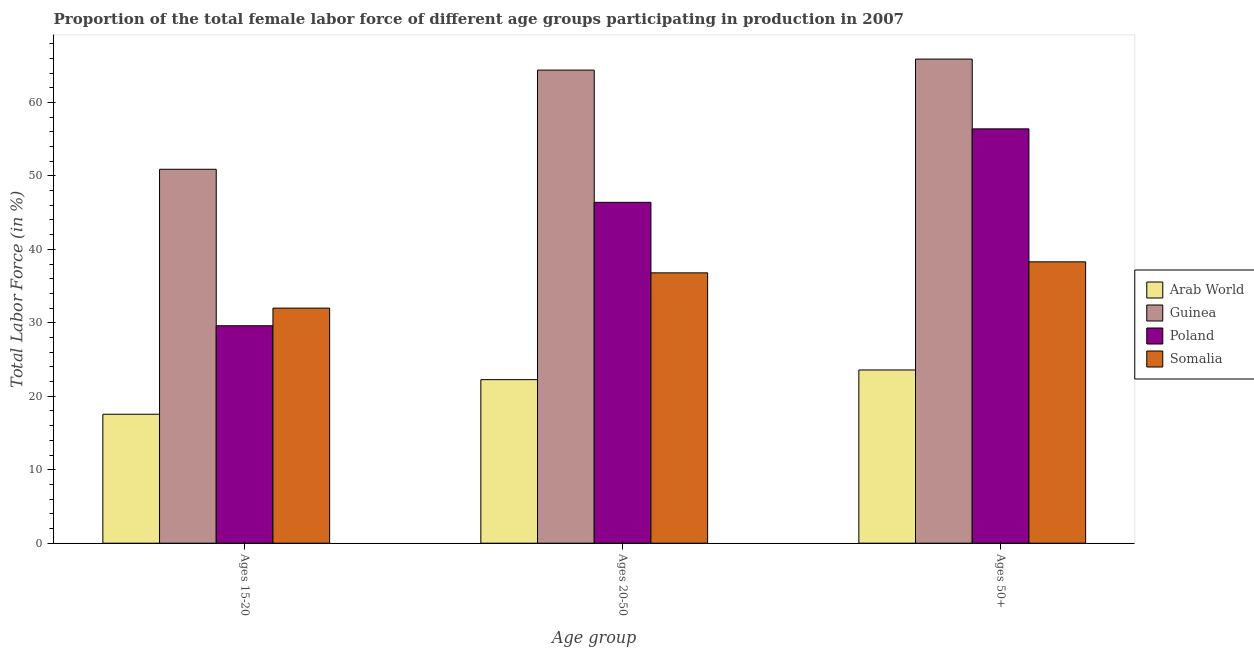How many groups of bars are there?
Give a very brief answer. 3. How many bars are there on the 1st tick from the left?
Make the answer very short. 4. How many bars are there on the 3rd tick from the right?
Your response must be concise. 4. What is the label of the 1st group of bars from the left?
Give a very brief answer. Ages 15-20. What is the percentage of female labor force within the age group 20-50 in Guinea?
Your answer should be compact. 64.4. Across all countries, what is the maximum percentage of female labor force within the age group 15-20?
Your answer should be compact. 50.9. Across all countries, what is the minimum percentage of female labor force within the age group 20-50?
Your answer should be compact. 22.26. In which country was the percentage of female labor force within the age group 15-20 maximum?
Your response must be concise. Guinea. In which country was the percentage of female labor force above age 50 minimum?
Keep it short and to the point. Arab World. What is the total percentage of female labor force within the age group 15-20 in the graph?
Make the answer very short. 130.05. What is the difference between the percentage of female labor force above age 50 in Poland and that in Somalia?
Offer a very short reply. 18.1. What is the average percentage of female labor force within the age group 20-50 per country?
Give a very brief answer. 42.47. What is the difference between the percentage of female labor force within the age group 15-20 and percentage of female labor force within the age group 20-50 in Poland?
Provide a short and direct response. -16.8. What is the ratio of the percentage of female labor force above age 50 in Guinea to that in Somalia?
Give a very brief answer. 1.72. Is the percentage of female labor force above age 50 in Guinea less than that in Somalia?
Your answer should be very brief. No. Is the difference between the percentage of female labor force within the age group 15-20 in Poland and Arab World greater than the difference between the percentage of female labor force above age 50 in Poland and Arab World?
Offer a very short reply. No. What is the difference between the highest and the second highest percentage of female labor force within the age group 15-20?
Ensure brevity in your answer.  18.9. What is the difference between the highest and the lowest percentage of female labor force within the age group 20-50?
Your response must be concise. 42.14. Is the sum of the percentage of female labor force within the age group 15-20 in Poland and Guinea greater than the maximum percentage of female labor force within the age group 20-50 across all countries?
Give a very brief answer. Yes. What does the 2nd bar from the left in Ages 15-20 represents?
Give a very brief answer. Guinea. What does the 3rd bar from the right in Ages 50+ represents?
Provide a short and direct response. Guinea. Is it the case that in every country, the sum of the percentage of female labor force within the age group 15-20 and percentage of female labor force within the age group 20-50 is greater than the percentage of female labor force above age 50?
Your answer should be very brief. Yes. How many bars are there?
Your answer should be compact. 12. Are all the bars in the graph horizontal?
Your answer should be very brief. No. How many countries are there in the graph?
Offer a terse response. 4. What is the difference between two consecutive major ticks on the Y-axis?
Your response must be concise. 10. Does the graph contain grids?
Keep it short and to the point. No. Where does the legend appear in the graph?
Make the answer very short. Center right. How many legend labels are there?
Your answer should be compact. 4. What is the title of the graph?
Provide a succinct answer. Proportion of the total female labor force of different age groups participating in production in 2007. Does "Channel Islands" appear as one of the legend labels in the graph?
Provide a succinct answer. No. What is the label or title of the X-axis?
Offer a very short reply. Age group. What is the Total Labor Force (in %) of Arab World in Ages 15-20?
Your answer should be compact. 17.55. What is the Total Labor Force (in %) in Guinea in Ages 15-20?
Your answer should be compact. 50.9. What is the Total Labor Force (in %) of Poland in Ages 15-20?
Your response must be concise. 29.6. What is the Total Labor Force (in %) of Somalia in Ages 15-20?
Your answer should be compact. 32. What is the Total Labor Force (in %) in Arab World in Ages 20-50?
Provide a short and direct response. 22.26. What is the Total Labor Force (in %) of Guinea in Ages 20-50?
Provide a succinct answer. 64.4. What is the Total Labor Force (in %) of Poland in Ages 20-50?
Keep it short and to the point. 46.4. What is the Total Labor Force (in %) in Somalia in Ages 20-50?
Offer a terse response. 36.8. What is the Total Labor Force (in %) in Arab World in Ages 50+?
Offer a terse response. 23.58. What is the Total Labor Force (in %) of Guinea in Ages 50+?
Ensure brevity in your answer.  65.9. What is the Total Labor Force (in %) of Poland in Ages 50+?
Ensure brevity in your answer.  56.4. What is the Total Labor Force (in %) of Somalia in Ages 50+?
Ensure brevity in your answer.  38.3. Across all Age group, what is the maximum Total Labor Force (in %) in Arab World?
Keep it short and to the point. 23.58. Across all Age group, what is the maximum Total Labor Force (in %) in Guinea?
Offer a very short reply. 65.9. Across all Age group, what is the maximum Total Labor Force (in %) in Poland?
Your response must be concise. 56.4. Across all Age group, what is the maximum Total Labor Force (in %) in Somalia?
Make the answer very short. 38.3. Across all Age group, what is the minimum Total Labor Force (in %) of Arab World?
Give a very brief answer. 17.55. Across all Age group, what is the minimum Total Labor Force (in %) in Guinea?
Your response must be concise. 50.9. Across all Age group, what is the minimum Total Labor Force (in %) in Poland?
Provide a short and direct response. 29.6. What is the total Total Labor Force (in %) of Arab World in the graph?
Make the answer very short. 63.4. What is the total Total Labor Force (in %) in Guinea in the graph?
Provide a succinct answer. 181.2. What is the total Total Labor Force (in %) of Poland in the graph?
Offer a very short reply. 132.4. What is the total Total Labor Force (in %) in Somalia in the graph?
Your response must be concise. 107.1. What is the difference between the Total Labor Force (in %) of Arab World in Ages 15-20 and that in Ages 20-50?
Your answer should be very brief. -4.71. What is the difference between the Total Labor Force (in %) in Poland in Ages 15-20 and that in Ages 20-50?
Make the answer very short. -16.8. What is the difference between the Total Labor Force (in %) in Somalia in Ages 15-20 and that in Ages 20-50?
Your answer should be compact. -4.8. What is the difference between the Total Labor Force (in %) of Arab World in Ages 15-20 and that in Ages 50+?
Provide a succinct answer. -6.03. What is the difference between the Total Labor Force (in %) in Poland in Ages 15-20 and that in Ages 50+?
Your answer should be very brief. -26.8. What is the difference between the Total Labor Force (in %) in Arab World in Ages 20-50 and that in Ages 50+?
Ensure brevity in your answer.  -1.32. What is the difference between the Total Labor Force (in %) of Guinea in Ages 20-50 and that in Ages 50+?
Your response must be concise. -1.5. What is the difference between the Total Labor Force (in %) of Poland in Ages 20-50 and that in Ages 50+?
Ensure brevity in your answer.  -10. What is the difference between the Total Labor Force (in %) in Somalia in Ages 20-50 and that in Ages 50+?
Keep it short and to the point. -1.5. What is the difference between the Total Labor Force (in %) in Arab World in Ages 15-20 and the Total Labor Force (in %) in Guinea in Ages 20-50?
Provide a short and direct response. -46.85. What is the difference between the Total Labor Force (in %) of Arab World in Ages 15-20 and the Total Labor Force (in %) of Poland in Ages 20-50?
Offer a terse response. -28.85. What is the difference between the Total Labor Force (in %) in Arab World in Ages 15-20 and the Total Labor Force (in %) in Somalia in Ages 20-50?
Make the answer very short. -19.25. What is the difference between the Total Labor Force (in %) in Poland in Ages 15-20 and the Total Labor Force (in %) in Somalia in Ages 20-50?
Your response must be concise. -7.2. What is the difference between the Total Labor Force (in %) in Arab World in Ages 15-20 and the Total Labor Force (in %) in Guinea in Ages 50+?
Give a very brief answer. -48.35. What is the difference between the Total Labor Force (in %) of Arab World in Ages 15-20 and the Total Labor Force (in %) of Poland in Ages 50+?
Keep it short and to the point. -38.85. What is the difference between the Total Labor Force (in %) of Arab World in Ages 15-20 and the Total Labor Force (in %) of Somalia in Ages 50+?
Provide a succinct answer. -20.75. What is the difference between the Total Labor Force (in %) of Guinea in Ages 15-20 and the Total Labor Force (in %) of Poland in Ages 50+?
Your answer should be very brief. -5.5. What is the difference between the Total Labor Force (in %) in Arab World in Ages 20-50 and the Total Labor Force (in %) in Guinea in Ages 50+?
Your answer should be very brief. -43.64. What is the difference between the Total Labor Force (in %) in Arab World in Ages 20-50 and the Total Labor Force (in %) in Poland in Ages 50+?
Give a very brief answer. -34.14. What is the difference between the Total Labor Force (in %) in Arab World in Ages 20-50 and the Total Labor Force (in %) in Somalia in Ages 50+?
Keep it short and to the point. -16.04. What is the difference between the Total Labor Force (in %) of Guinea in Ages 20-50 and the Total Labor Force (in %) of Somalia in Ages 50+?
Provide a short and direct response. 26.1. What is the difference between the Total Labor Force (in %) in Poland in Ages 20-50 and the Total Labor Force (in %) in Somalia in Ages 50+?
Give a very brief answer. 8.1. What is the average Total Labor Force (in %) of Arab World per Age group?
Provide a short and direct response. 21.13. What is the average Total Labor Force (in %) in Guinea per Age group?
Keep it short and to the point. 60.4. What is the average Total Labor Force (in %) in Poland per Age group?
Give a very brief answer. 44.13. What is the average Total Labor Force (in %) in Somalia per Age group?
Your response must be concise. 35.7. What is the difference between the Total Labor Force (in %) of Arab World and Total Labor Force (in %) of Guinea in Ages 15-20?
Provide a short and direct response. -33.35. What is the difference between the Total Labor Force (in %) of Arab World and Total Labor Force (in %) of Poland in Ages 15-20?
Your answer should be very brief. -12.05. What is the difference between the Total Labor Force (in %) of Arab World and Total Labor Force (in %) of Somalia in Ages 15-20?
Your answer should be compact. -14.45. What is the difference between the Total Labor Force (in %) of Guinea and Total Labor Force (in %) of Poland in Ages 15-20?
Offer a terse response. 21.3. What is the difference between the Total Labor Force (in %) of Guinea and Total Labor Force (in %) of Somalia in Ages 15-20?
Your answer should be very brief. 18.9. What is the difference between the Total Labor Force (in %) of Arab World and Total Labor Force (in %) of Guinea in Ages 20-50?
Your response must be concise. -42.14. What is the difference between the Total Labor Force (in %) in Arab World and Total Labor Force (in %) in Poland in Ages 20-50?
Provide a short and direct response. -24.14. What is the difference between the Total Labor Force (in %) of Arab World and Total Labor Force (in %) of Somalia in Ages 20-50?
Your answer should be very brief. -14.54. What is the difference between the Total Labor Force (in %) of Guinea and Total Labor Force (in %) of Somalia in Ages 20-50?
Provide a succinct answer. 27.6. What is the difference between the Total Labor Force (in %) of Arab World and Total Labor Force (in %) of Guinea in Ages 50+?
Ensure brevity in your answer.  -42.32. What is the difference between the Total Labor Force (in %) of Arab World and Total Labor Force (in %) of Poland in Ages 50+?
Your answer should be compact. -32.82. What is the difference between the Total Labor Force (in %) of Arab World and Total Labor Force (in %) of Somalia in Ages 50+?
Your answer should be very brief. -14.72. What is the difference between the Total Labor Force (in %) of Guinea and Total Labor Force (in %) of Somalia in Ages 50+?
Offer a terse response. 27.6. What is the ratio of the Total Labor Force (in %) in Arab World in Ages 15-20 to that in Ages 20-50?
Your response must be concise. 0.79. What is the ratio of the Total Labor Force (in %) in Guinea in Ages 15-20 to that in Ages 20-50?
Give a very brief answer. 0.79. What is the ratio of the Total Labor Force (in %) in Poland in Ages 15-20 to that in Ages 20-50?
Offer a very short reply. 0.64. What is the ratio of the Total Labor Force (in %) of Somalia in Ages 15-20 to that in Ages 20-50?
Offer a terse response. 0.87. What is the ratio of the Total Labor Force (in %) in Arab World in Ages 15-20 to that in Ages 50+?
Provide a succinct answer. 0.74. What is the ratio of the Total Labor Force (in %) in Guinea in Ages 15-20 to that in Ages 50+?
Provide a succinct answer. 0.77. What is the ratio of the Total Labor Force (in %) in Poland in Ages 15-20 to that in Ages 50+?
Give a very brief answer. 0.52. What is the ratio of the Total Labor Force (in %) of Somalia in Ages 15-20 to that in Ages 50+?
Your response must be concise. 0.84. What is the ratio of the Total Labor Force (in %) in Arab World in Ages 20-50 to that in Ages 50+?
Offer a very short reply. 0.94. What is the ratio of the Total Labor Force (in %) in Guinea in Ages 20-50 to that in Ages 50+?
Your answer should be very brief. 0.98. What is the ratio of the Total Labor Force (in %) in Poland in Ages 20-50 to that in Ages 50+?
Your answer should be very brief. 0.82. What is the ratio of the Total Labor Force (in %) in Somalia in Ages 20-50 to that in Ages 50+?
Ensure brevity in your answer.  0.96. What is the difference between the highest and the second highest Total Labor Force (in %) of Arab World?
Keep it short and to the point. 1.32. What is the difference between the highest and the second highest Total Labor Force (in %) of Guinea?
Your answer should be very brief. 1.5. What is the difference between the highest and the second highest Total Labor Force (in %) in Somalia?
Your answer should be very brief. 1.5. What is the difference between the highest and the lowest Total Labor Force (in %) in Arab World?
Ensure brevity in your answer.  6.03. What is the difference between the highest and the lowest Total Labor Force (in %) in Guinea?
Your answer should be very brief. 15. What is the difference between the highest and the lowest Total Labor Force (in %) of Poland?
Make the answer very short. 26.8. 